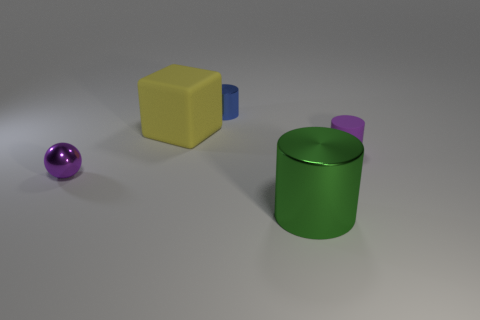Add 1 blue cylinders. How many objects exist? 6 Subtract all cubes. How many objects are left? 4 Add 3 small green shiny cubes. How many small green shiny cubes exist? 3 Subtract 0 cyan cylinders. How many objects are left? 5 Subtract all small cyan metal cylinders. Subtract all metal cylinders. How many objects are left? 3 Add 1 purple rubber objects. How many purple rubber objects are left? 2 